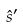<formula> <loc_0><loc_0><loc_500><loc_500>\hat { s } ^ { \prime }</formula> 